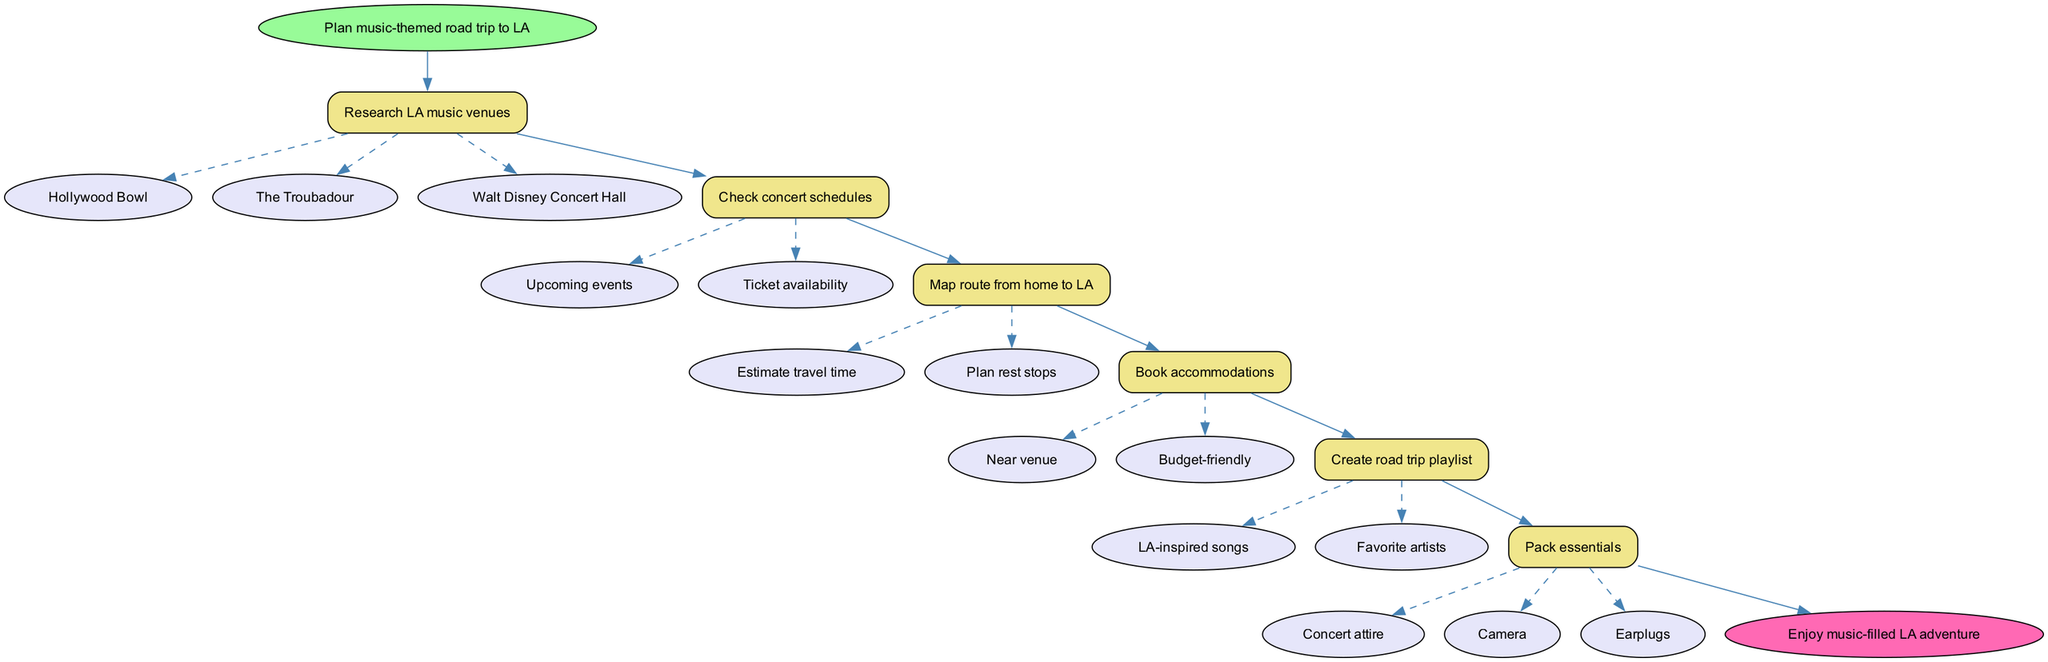What is the first step in the diagram? The diagram begins with the node labeled "Plan music-themed road trip to LA," indicating that this is the initial action to take.
Answer: Plan music-themed road trip to LA How many music venues are listed in the diagram? There are three music venues mentioned in the options of the "Research LA music venues" step: Hollywood Bowl, The Troubadour, and Walt Disney Concert Hall, totaling three.
Answer: 3 What is the last action before arriving at the end node? The last action taken before moving to the end node is to "Pack essentials," as it is linked directly to the final step in the process.
Answer: Pack essentials Which action involves checking future events? The action titled "Check concert schedules" involves checking for upcoming events, as identified among the options under this step.
Answer: Check concert schedules What is the estimated travel time associated with which step? The step "Map route from home to LA" includes the option "Estimate travel time," indicating that it relates to planning the trip's duration.
Answer: Map route from home to LA How many options are available under "Book accommodations"? There are two options listed under "Book accommodations": "Near venue" and "Budget-friendly," which totals to two options available for this step.
Answer: 2 What is the purpose of the "Create road trip playlist" action? The purpose of the "Create road trip playlist" action is to prepare a playlist with "LA-inspired songs" and "Favorite artists," indicating it's meant for entertainment during the trip.
Answer: Create road trip playlist Which option is linked to packing items? The "Pack essentials" step functions as a concluding action with options for "Concert attire," "Camera," and "Earplugs," indicating they are items directly linked to packing.
Answer: Pack essentials 